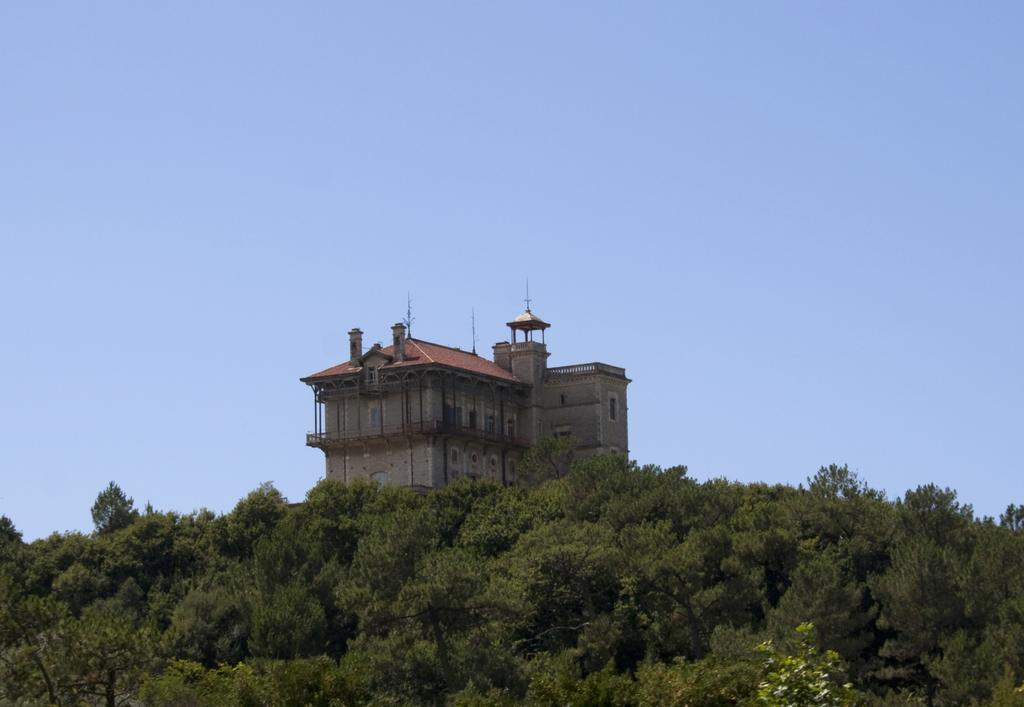What type of vegetation is in the foreground of the image? There are trees in the foreground of the image. What structure is located in the middle of the image? There is a building in the middle of the image. What color is the sky visible in the background of the image? The blue sky is visible in the background of the image. What type of letters can be seen on the building in the image? There are no letters visible on the building in the image. What color is the marble used for the flooring in the image? There is no marble present in the image; it features trees, a building, and the blue sky. 